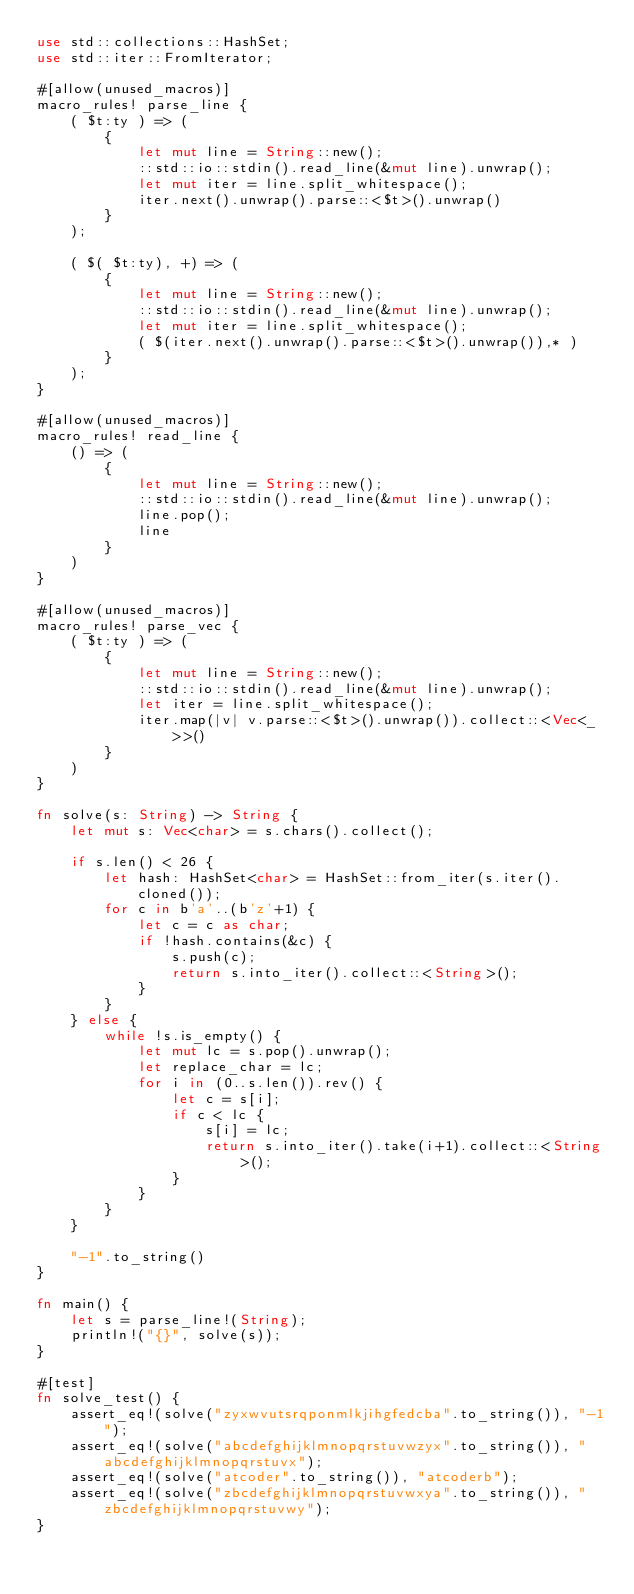Convert code to text. <code><loc_0><loc_0><loc_500><loc_500><_Rust_>use std::collections::HashSet;
use std::iter::FromIterator;

#[allow(unused_macros)]
macro_rules! parse_line {
    ( $t:ty ) => (
        {
            let mut line = String::new();
            ::std::io::stdin().read_line(&mut line).unwrap();
            let mut iter = line.split_whitespace();
            iter.next().unwrap().parse::<$t>().unwrap()
        }
    );

    ( $( $t:ty), +) => (
        {
            let mut line = String::new();
            ::std::io::stdin().read_line(&mut line).unwrap();
            let mut iter = line.split_whitespace();
            ( $(iter.next().unwrap().parse::<$t>().unwrap()),* )
        }
    );
}

#[allow(unused_macros)]
macro_rules! read_line {
    () => (
        {
            let mut line = String::new();
            ::std::io::stdin().read_line(&mut line).unwrap();
            line.pop();
            line
        }
    )
}

#[allow(unused_macros)]
macro_rules! parse_vec {
    ( $t:ty ) => (
        {
            let mut line = String::new();
            ::std::io::stdin().read_line(&mut line).unwrap();
            let iter = line.split_whitespace();
            iter.map(|v| v.parse::<$t>().unwrap()).collect::<Vec<_>>()
        }
    )
}

fn solve(s: String) -> String {
    let mut s: Vec<char> = s.chars().collect();

    if s.len() < 26 {
        let hash: HashSet<char> = HashSet::from_iter(s.iter().cloned());
        for c in b'a'..(b'z'+1) {
            let c = c as char;
            if !hash.contains(&c) {
                s.push(c);
                return s.into_iter().collect::<String>();
            }
        }
    } else {
        while !s.is_empty() {
            let mut lc = s.pop().unwrap();
            let replace_char = lc;
            for i in (0..s.len()).rev() {
                let c = s[i];
                if c < lc {
                    s[i] = lc;
                    return s.into_iter().take(i+1).collect::<String>();
                }
            }
        }
    }

    "-1".to_string()
}

fn main() {
    let s = parse_line!(String);
    println!("{}", solve(s));
}

#[test]
fn solve_test() {
    assert_eq!(solve("zyxwvutsrqponmlkjihgfedcba".to_string()), "-1");
    assert_eq!(solve("abcdefghijklmnopqrstuvwzyx".to_string()), "abcdefghijklmnopqrstuvx");
    assert_eq!(solve("atcoder".to_string()), "atcoderb");
    assert_eq!(solve("zbcdefghijklmnopqrstuvwxya".to_string()), "zbcdefghijklmnopqrstuvwy");
}
</code> 